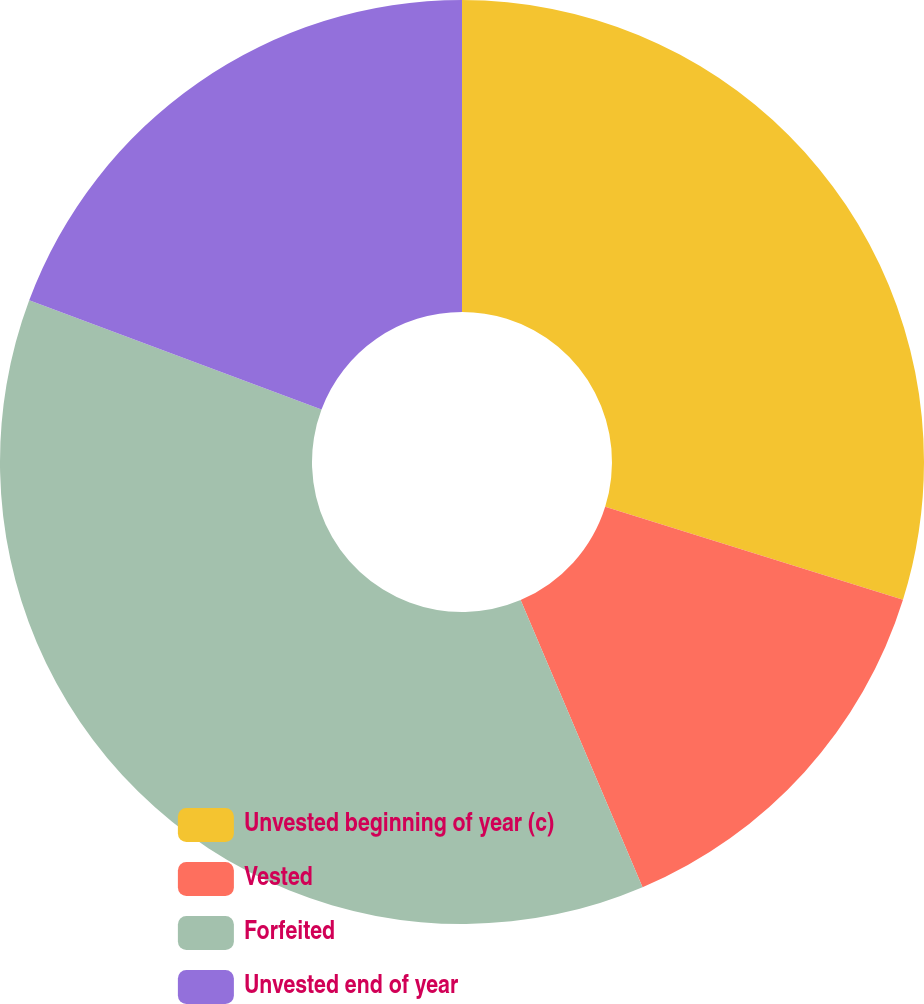Convert chart to OTSL. <chart><loc_0><loc_0><loc_500><loc_500><pie_chart><fcel>Unvested beginning of year (c)<fcel>Vested<fcel>Forfeited<fcel>Unvested end of year<nl><fcel>29.82%<fcel>13.79%<fcel>37.08%<fcel>19.31%<nl></chart> 